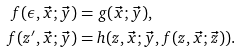Convert formula to latex. <formula><loc_0><loc_0><loc_500><loc_500>f ( \epsilon , \vec { x } ; \vec { y } ) & = g ( \vec { x } ; \vec { y } ) , \\ f ( z ^ { \prime } , \vec { x } ; \vec { y } ) & = h ( z , \vec { x } ; \vec { y } , f ( z , \vec { x } ; \vec { z } ) ) .</formula> 